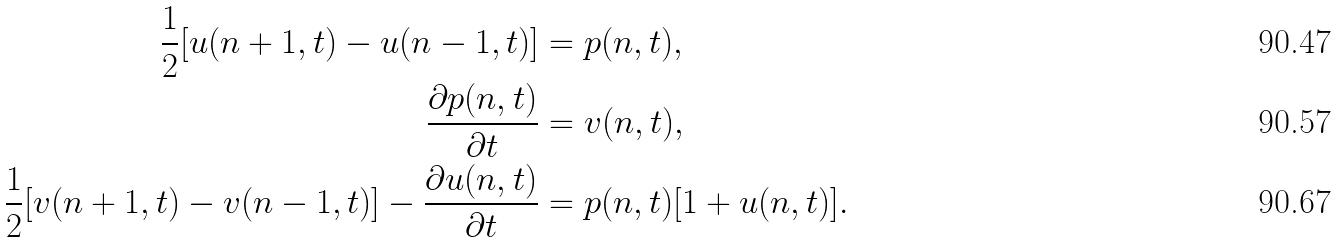Convert formula to latex. <formula><loc_0><loc_0><loc_500><loc_500>\frac { 1 } { 2 } [ u ( n + 1 , t ) - u ( n - 1 , t ) ] & = p ( n , t ) , \\ \frac { \partial p ( n , t ) } { \partial t } & = v ( n , t ) , \\ \frac { 1 } { 2 } [ v ( n + 1 , t ) - v ( n - 1 , t ) ] - \frac { \partial u ( n , t ) } { \partial t } & = p ( n , t ) [ 1 + u ( n , t ) ] .</formula> 